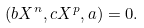<formula> <loc_0><loc_0><loc_500><loc_500>( b X ^ { n } , c X ^ { p } , a ) = 0 .</formula> 